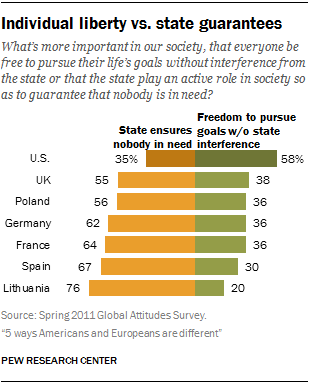Specify some key components in this picture. There are seven categories in the chart. The highest yellow bar is different from the highest green bar by 18... 